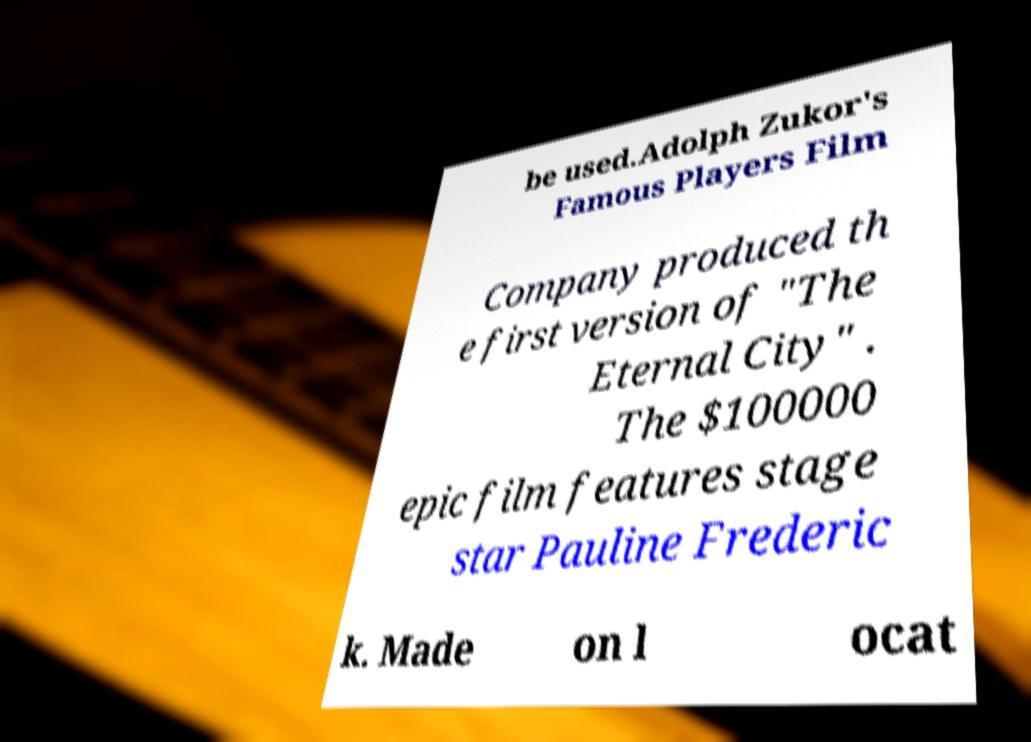Please read and relay the text visible in this image. What does it say? be used.Adolph Zukor's Famous Players Film Company produced th e first version of "The Eternal City" . The $100000 epic film features stage star Pauline Frederic k. Made on l ocat 